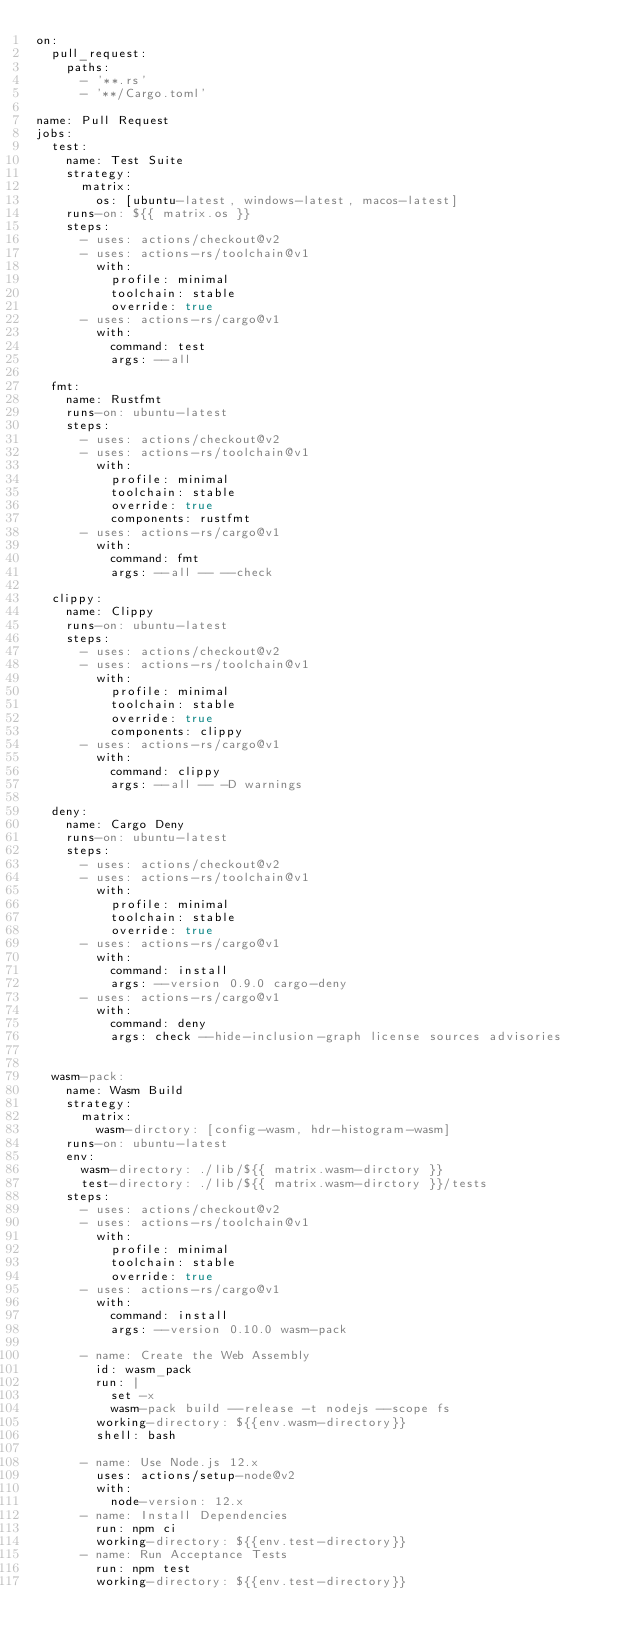Convert code to text. <code><loc_0><loc_0><loc_500><loc_500><_YAML_>on:
  pull_request:
    paths:
      - '**.rs'
      - '**/Cargo.toml'

name: Pull Request
jobs:
  test:
    name: Test Suite
    strategy:
      matrix:
        os: [ubuntu-latest, windows-latest, macos-latest]
    runs-on: ${{ matrix.os }}
    steps:
      - uses: actions/checkout@v2
      - uses: actions-rs/toolchain@v1
        with:
          profile: minimal
          toolchain: stable
          override: true
      - uses: actions-rs/cargo@v1
        with:
          command: test
          args: --all

  fmt:
    name: Rustfmt
    runs-on: ubuntu-latest
    steps:
      - uses: actions/checkout@v2
      - uses: actions-rs/toolchain@v1
        with:
          profile: minimal
          toolchain: stable
          override: true
          components: rustfmt
      - uses: actions-rs/cargo@v1
        with:
          command: fmt
          args: --all -- --check

  clippy:
    name: Clippy
    runs-on: ubuntu-latest
    steps:
      - uses: actions/checkout@v2
      - uses: actions-rs/toolchain@v1
        with:
          profile: minimal
          toolchain: stable
          override: true
          components: clippy 
      - uses: actions-rs/cargo@v1
        with:
          command: clippy
          args: --all -- -D warnings

  deny:
    name: Cargo Deny
    runs-on: ubuntu-latest
    steps:
      - uses: actions/checkout@v2
      - uses: actions-rs/toolchain@v1
        with:
          profile: minimal
          toolchain: stable
          override: true
      - uses: actions-rs/cargo@v1
        with:
          command: install
          args: --version 0.9.0 cargo-deny
      - uses: actions-rs/cargo@v1
        with:
          command: deny
          args: check --hide-inclusion-graph license sources advisories


  wasm-pack:
    name: Wasm Build
    strategy:
      matrix:
        wasm-dirctory: [config-wasm, hdr-histogram-wasm]
    runs-on: ubuntu-latest
    env:
      wasm-directory: ./lib/${{ matrix.wasm-dirctory }}
      test-directory: ./lib/${{ matrix.wasm-dirctory }}/tests
    steps:
      - uses: actions/checkout@v2
      - uses: actions-rs/toolchain@v1
        with:
          profile: minimal
          toolchain: stable
          override: true
      - uses: actions-rs/cargo@v1
        with:
          command: install
          args: --version 0.10.0 wasm-pack

      - name: Create the Web Assembly
        id: wasm_pack
        run: |
          set -x
          wasm-pack build --release -t nodejs --scope fs
        working-directory: ${{env.wasm-directory}}
        shell: bash

      - name: Use Node.js 12.x
        uses: actions/setup-node@v2
        with:
          node-version: 12.x
      - name: Install Dependencies
        run: npm ci
        working-directory: ${{env.test-directory}}
      - name: Run Acceptance Tests
        run: npm test
        working-directory: ${{env.test-directory}}
</code> 